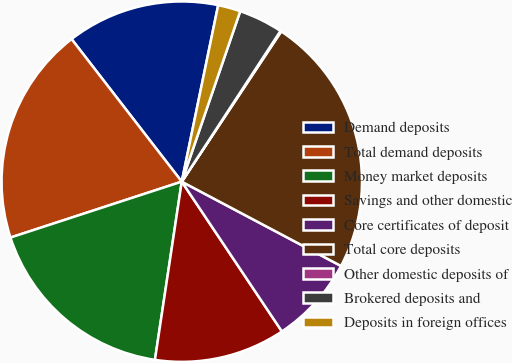Convert chart. <chart><loc_0><loc_0><loc_500><loc_500><pie_chart><fcel>Demand deposits<fcel>Total demand deposits<fcel>Money market deposits<fcel>Savings and other domestic<fcel>Core certificates of deposit<fcel>Total core deposits<fcel>Other domestic deposits of<fcel>Brokered deposits and<fcel>Deposits in foreign offices<nl><fcel>13.71%<fcel>19.55%<fcel>17.6%<fcel>11.76%<fcel>7.87%<fcel>23.44%<fcel>0.08%<fcel>3.97%<fcel>2.02%<nl></chart> 